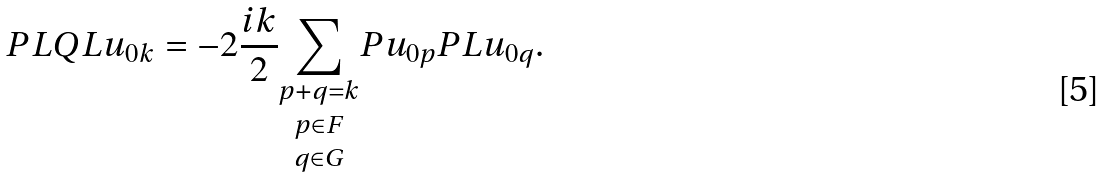Convert formula to latex. <formula><loc_0><loc_0><loc_500><loc_500>P L Q L u _ { 0 k } = - 2 \frac { i k } { 2 } \underset { q \in G } { \underset { p \in F } { \underset { p + q = k } { \sum } } } P u _ { 0 p } P L u _ { 0 q } .</formula> 